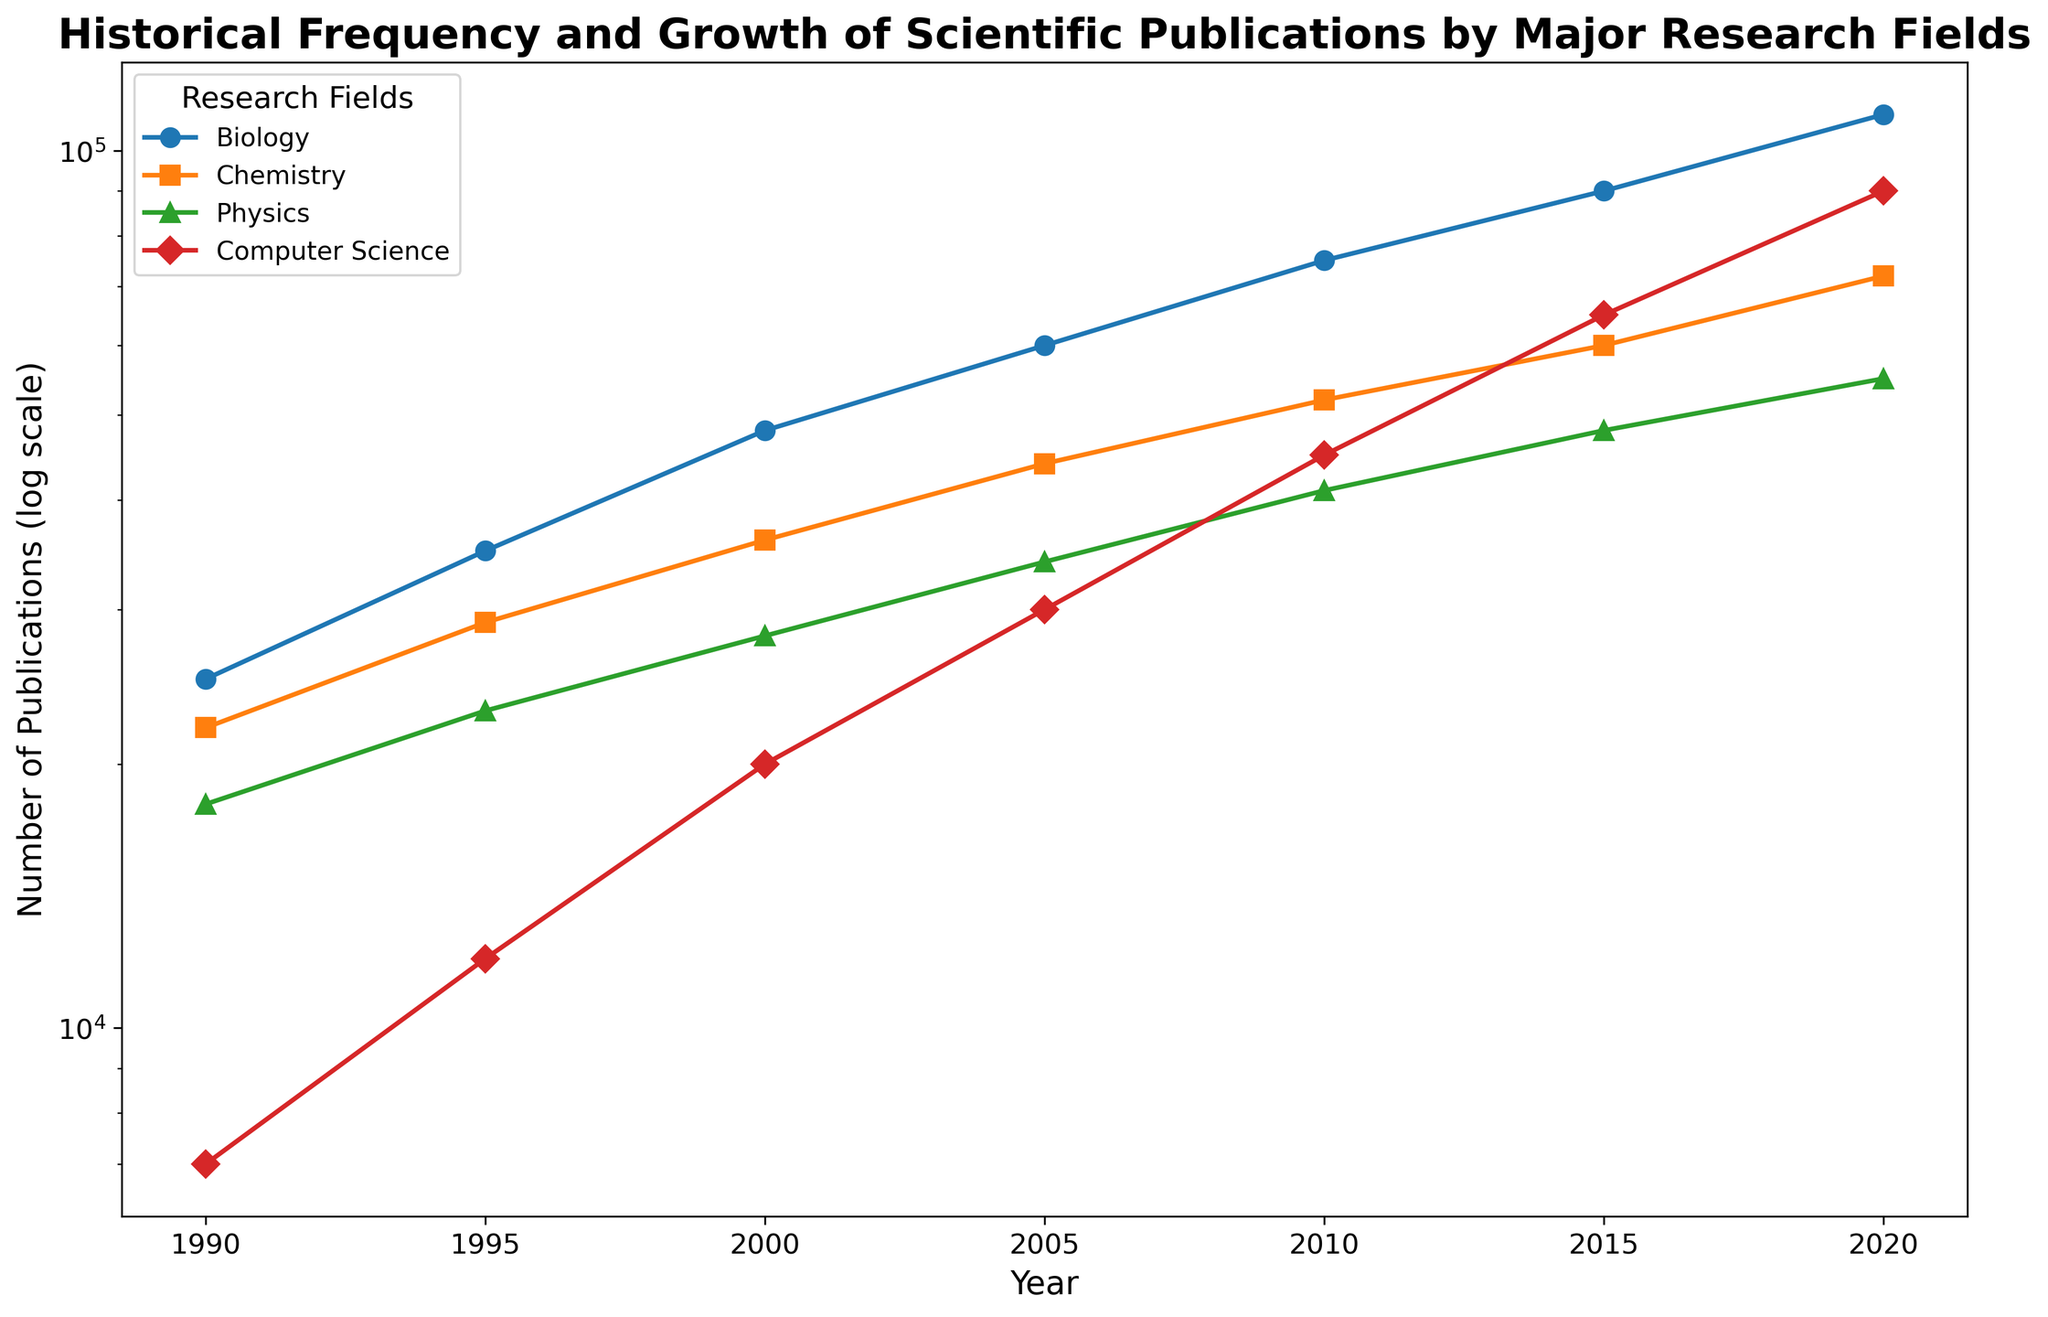What's the research field with the highest number of publications in 2020? Look at the endpoints of the lines on the right part of the chart, and identify the one that appears highest.
Answer: Biology Which research field saw the largest growth in the number of publications between 1990 and 2020? Compare the starting and ending points of each line for the four research fields. Subtract the 1990 value from the 2020 value for each field to determine the growth.
Answer: Computer Science How does the number of publications in Chemistry in 2010 compare with Physics in the same year? Locate the points for Chemistry and Physics in 2010 and compare their height on the y-axis.
Answer: Chemistry had more publications Between which two consecutive years did Computer Science see the largest spike in publications? Look at the red line and determine the periods where the line’s slope is the steepest.
Answer: 2015 to 2020 What's the average number of publications in Biology across the years displayed in the figure? Add the number of publications in Biology for each year listed, then divide by the total number of years.
Answer: 59,167 Which research field had the least publications in 1990? Identify the lowest point among the 1990 data on the left side of the chart.
Answer: Computer Science In what year does Physics first surpass 50,000 publications? Follow the green line and determine the first point in time where it crosses the 50,000 mark on the log scale.
Answer: 2020 Is the growth pattern of publications over time in Chemistry more similar to Biology or Physics? Compare the shape and trend of the Chemistry line (orange) with those of Biology (blue) and Physics (green) to see which it resembles more.
Answer: Physics What is the sum of the publications in all fields in the year 2000? Add the number of publications for all four fields in the year 2000.
Answer: 132,000 Which research field shows a steady growth without any decrease over the years? Observe the lines representing each field to see which one consistently rises without any dips.
Answer: Computer Science 